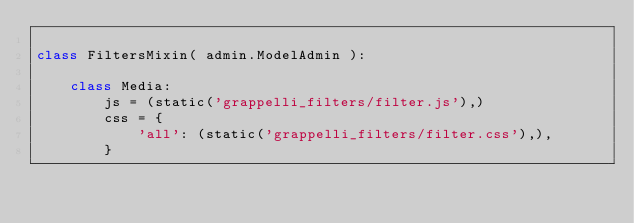<code> <loc_0><loc_0><loc_500><loc_500><_Python_>
class FiltersMixin( admin.ModelAdmin ):

    class Media:
        js = (static('grappelli_filters/filter.js'),)
        css = {
            'all': (static('grappelli_filters/filter.css'),),
        }
</code> 